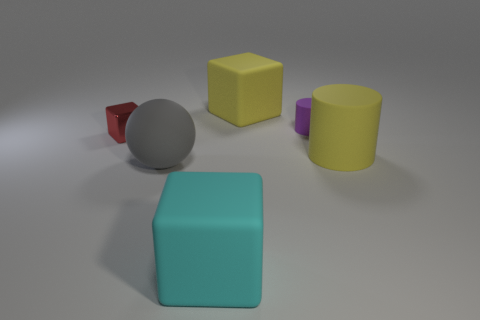There is a tiny thing that is on the left side of the large cyan rubber thing; is its shape the same as the cyan matte object?
Offer a very short reply. Yes. What shape is the thing that is the same color as the big cylinder?
Give a very brief answer. Cube. There is a large matte cylinder; is its color the same as the big matte object behind the shiny object?
Your response must be concise. Yes. There is a matte block that is the same color as the large cylinder; what size is it?
Keep it short and to the point. Large. There is a cyan block that is to the left of the tiny purple rubber cylinder; does it have the same size as the cube that is left of the cyan block?
Make the answer very short. No. Is there a big thing that has the same color as the big matte cylinder?
Your answer should be very brief. Yes. Are any tiny purple matte cylinders visible?
Ensure brevity in your answer.  Yes. What color is the large rubber cube that is behind the large sphere?
Provide a short and direct response. Yellow. Does the red shiny thing have the same size as the rubber block in front of the large yellow block?
Your response must be concise. No. There is a cube that is both to the right of the red thing and behind the big cylinder; what size is it?
Give a very brief answer. Large. 